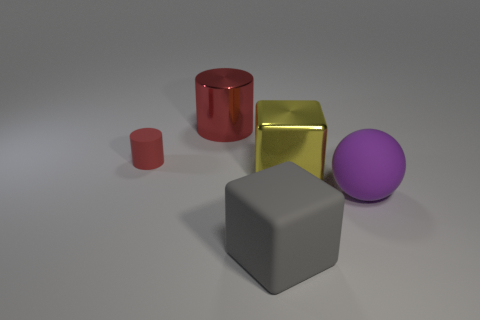There is a gray thing that is the same size as the purple rubber thing; what is it made of?
Offer a very short reply. Rubber. How many other objects are the same size as the yellow metallic object?
Your response must be concise. 3. What number of balls are either small rubber objects or big purple things?
Your answer should be compact. 1. Is there anything else that has the same material as the large gray cube?
Offer a very short reply. Yes. What material is the big cube in front of the shiny object that is in front of the red cylinder to the left of the shiny cylinder made of?
Keep it short and to the point. Rubber. What is the material of the object that is the same color as the small rubber cylinder?
Offer a very short reply. Metal. How many small red cylinders are the same material as the big yellow block?
Make the answer very short. 0. There is a block behind the matte sphere; is its size the same as the red metallic cylinder?
Keep it short and to the point. Yes. What is the color of the sphere that is the same material as the small object?
Offer a terse response. Purple. Is there anything else that is the same size as the yellow metallic thing?
Your answer should be compact. Yes. 